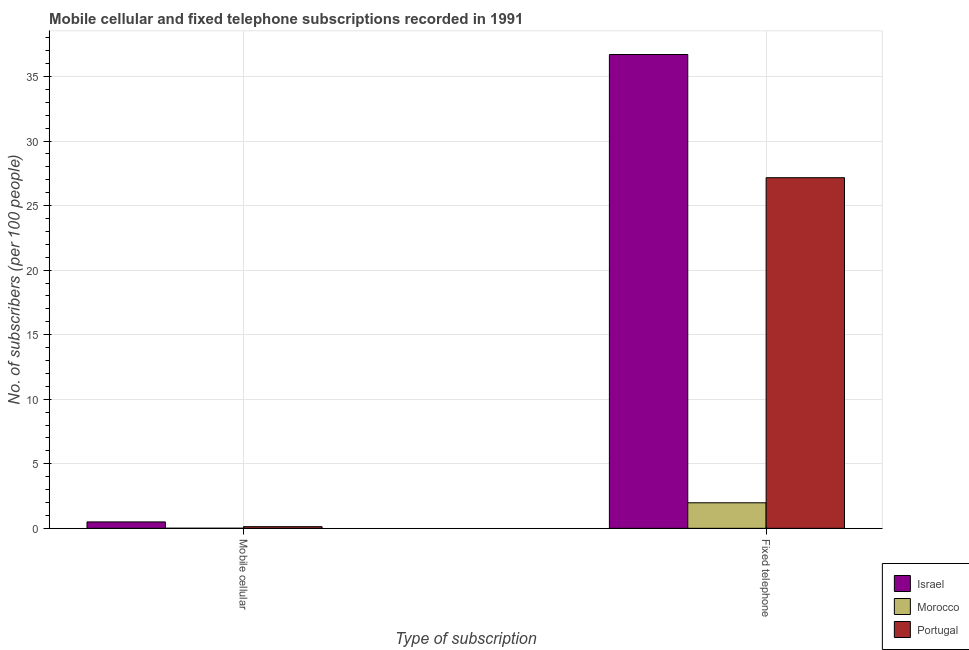What is the label of the 2nd group of bars from the left?
Ensure brevity in your answer.  Fixed telephone. What is the number of fixed telephone subscribers in Morocco?
Make the answer very short. 1.98. Across all countries, what is the maximum number of mobile cellular subscribers?
Your answer should be very brief. 0.5. Across all countries, what is the minimum number of fixed telephone subscribers?
Provide a short and direct response. 1.98. In which country was the number of fixed telephone subscribers maximum?
Give a very brief answer. Israel. In which country was the number of mobile cellular subscribers minimum?
Provide a succinct answer. Morocco. What is the total number of mobile cellular subscribers in the graph?
Ensure brevity in your answer.  0.63. What is the difference between the number of mobile cellular subscribers in Portugal and that in Israel?
Provide a short and direct response. -0.37. What is the difference between the number of fixed telephone subscribers in Israel and the number of mobile cellular subscribers in Portugal?
Keep it short and to the point. 36.57. What is the average number of mobile cellular subscribers per country?
Make the answer very short. 0.21. What is the difference between the number of mobile cellular subscribers and number of fixed telephone subscribers in Portugal?
Your response must be concise. -27.03. What is the ratio of the number of mobile cellular subscribers in Israel to that in Portugal?
Give a very brief answer. 3.9. Is the number of mobile cellular subscribers in Israel less than that in Portugal?
Your answer should be compact. No. In how many countries, is the number of fixed telephone subscribers greater than the average number of fixed telephone subscribers taken over all countries?
Offer a very short reply. 2. What does the 2nd bar from the right in Fixed telephone represents?
Your response must be concise. Morocco. Are all the bars in the graph horizontal?
Keep it short and to the point. No. Are the values on the major ticks of Y-axis written in scientific E-notation?
Your answer should be compact. No. Does the graph contain any zero values?
Give a very brief answer. No. Does the graph contain grids?
Give a very brief answer. Yes. How many legend labels are there?
Give a very brief answer. 3. How are the legend labels stacked?
Provide a succinct answer. Vertical. What is the title of the graph?
Make the answer very short. Mobile cellular and fixed telephone subscriptions recorded in 1991. Does "Korea (Democratic)" appear as one of the legend labels in the graph?
Your response must be concise. No. What is the label or title of the X-axis?
Provide a succinct answer. Type of subscription. What is the label or title of the Y-axis?
Your answer should be compact. No. of subscribers (per 100 people). What is the No. of subscribers (per 100 people) in Israel in Mobile cellular?
Provide a short and direct response. 0.5. What is the No. of subscribers (per 100 people) of Morocco in Mobile cellular?
Offer a terse response. 0.01. What is the No. of subscribers (per 100 people) of Portugal in Mobile cellular?
Offer a very short reply. 0.13. What is the No. of subscribers (per 100 people) in Israel in Fixed telephone?
Offer a terse response. 36.7. What is the No. of subscribers (per 100 people) of Morocco in Fixed telephone?
Your answer should be compact. 1.98. What is the No. of subscribers (per 100 people) of Portugal in Fixed telephone?
Your answer should be compact. 27.16. Across all Type of subscription, what is the maximum No. of subscribers (per 100 people) of Israel?
Your response must be concise. 36.7. Across all Type of subscription, what is the maximum No. of subscribers (per 100 people) of Morocco?
Keep it short and to the point. 1.98. Across all Type of subscription, what is the maximum No. of subscribers (per 100 people) in Portugal?
Provide a short and direct response. 27.16. Across all Type of subscription, what is the minimum No. of subscribers (per 100 people) of Israel?
Offer a terse response. 0.5. Across all Type of subscription, what is the minimum No. of subscribers (per 100 people) of Morocco?
Provide a succinct answer. 0.01. Across all Type of subscription, what is the minimum No. of subscribers (per 100 people) of Portugal?
Provide a short and direct response. 0.13. What is the total No. of subscribers (per 100 people) of Israel in the graph?
Your answer should be very brief. 37.2. What is the total No. of subscribers (per 100 people) in Morocco in the graph?
Offer a terse response. 1.98. What is the total No. of subscribers (per 100 people) in Portugal in the graph?
Provide a short and direct response. 27.29. What is the difference between the No. of subscribers (per 100 people) of Israel in Mobile cellular and that in Fixed telephone?
Your response must be concise. -36.2. What is the difference between the No. of subscribers (per 100 people) in Morocco in Mobile cellular and that in Fixed telephone?
Offer a terse response. -1.97. What is the difference between the No. of subscribers (per 100 people) of Portugal in Mobile cellular and that in Fixed telephone?
Keep it short and to the point. -27.03. What is the difference between the No. of subscribers (per 100 people) of Israel in Mobile cellular and the No. of subscribers (per 100 people) of Morocco in Fixed telephone?
Your answer should be compact. -1.48. What is the difference between the No. of subscribers (per 100 people) of Israel in Mobile cellular and the No. of subscribers (per 100 people) of Portugal in Fixed telephone?
Keep it short and to the point. -26.66. What is the difference between the No. of subscribers (per 100 people) in Morocco in Mobile cellular and the No. of subscribers (per 100 people) in Portugal in Fixed telephone?
Give a very brief answer. -27.15. What is the average No. of subscribers (per 100 people) of Israel per Type of subscription?
Keep it short and to the point. 18.6. What is the average No. of subscribers (per 100 people) of Morocco per Type of subscription?
Ensure brevity in your answer.  0.99. What is the average No. of subscribers (per 100 people) of Portugal per Type of subscription?
Offer a terse response. 13.64. What is the difference between the No. of subscribers (per 100 people) of Israel and No. of subscribers (per 100 people) of Morocco in Mobile cellular?
Your answer should be compact. 0.49. What is the difference between the No. of subscribers (per 100 people) in Israel and No. of subscribers (per 100 people) in Portugal in Mobile cellular?
Provide a short and direct response. 0.37. What is the difference between the No. of subscribers (per 100 people) of Morocco and No. of subscribers (per 100 people) of Portugal in Mobile cellular?
Keep it short and to the point. -0.12. What is the difference between the No. of subscribers (per 100 people) of Israel and No. of subscribers (per 100 people) of Morocco in Fixed telephone?
Your answer should be very brief. 34.72. What is the difference between the No. of subscribers (per 100 people) of Israel and No. of subscribers (per 100 people) of Portugal in Fixed telephone?
Make the answer very short. 9.54. What is the difference between the No. of subscribers (per 100 people) in Morocco and No. of subscribers (per 100 people) in Portugal in Fixed telephone?
Keep it short and to the point. -25.18. What is the ratio of the No. of subscribers (per 100 people) in Israel in Mobile cellular to that in Fixed telephone?
Make the answer very short. 0.01. What is the ratio of the No. of subscribers (per 100 people) in Morocco in Mobile cellular to that in Fixed telephone?
Your response must be concise. 0. What is the ratio of the No. of subscribers (per 100 people) in Portugal in Mobile cellular to that in Fixed telephone?
Make the answer very short. 0. What is the difference between the highest and the second highest No. of subscribers (per 100 people) of Israel?
Provide a succinct answer. 36.2. What is the difference between the highest and the second highest No. of subscribers (per 100 people) in Morocco?
Your answer should be very brief. 1.97. What is the difference between the highest and the second highest No. of subscribers (per 100 people) in Portugal?
Keep it short and to the point. 27.03. What is the difference between the highest and the lowest No. of subscribers (per 100 people) of Israel?
Give a very brief answer. 36.2. What is the difference between the highest and the lowest No. of subscribers (per 100 people) of Morocco?
Keep it short and to the point. 1.97. What is the difference between the highest and the lowest No. of subscribers (per 100 people) in Portugal?
Provide a short and direct response. 27.03. 